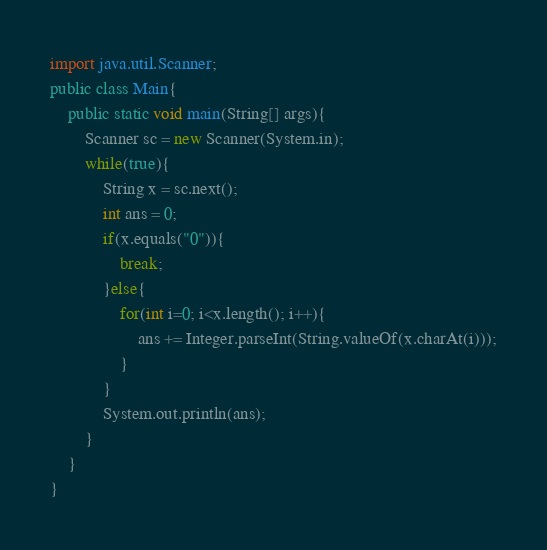<code> <loc_0><loc_0><loc_500><loc_500><_Java_>import java.util.Scanner;
public class Main{
    public static void main(String[] args){
        Scanner sc = new Scanner(System.in);
		while(true){
            String x = sc.next();
			int ans = 0;
			if(x.equals("0")){
				break;
			}else{
				for(int i=0; i<x.length(); i++){
					ans += Integer.parseInt(String.valueOf(x.charAt(i)));
				}
			}
			System.out.println(ans);
		}
	}
}

</code> 